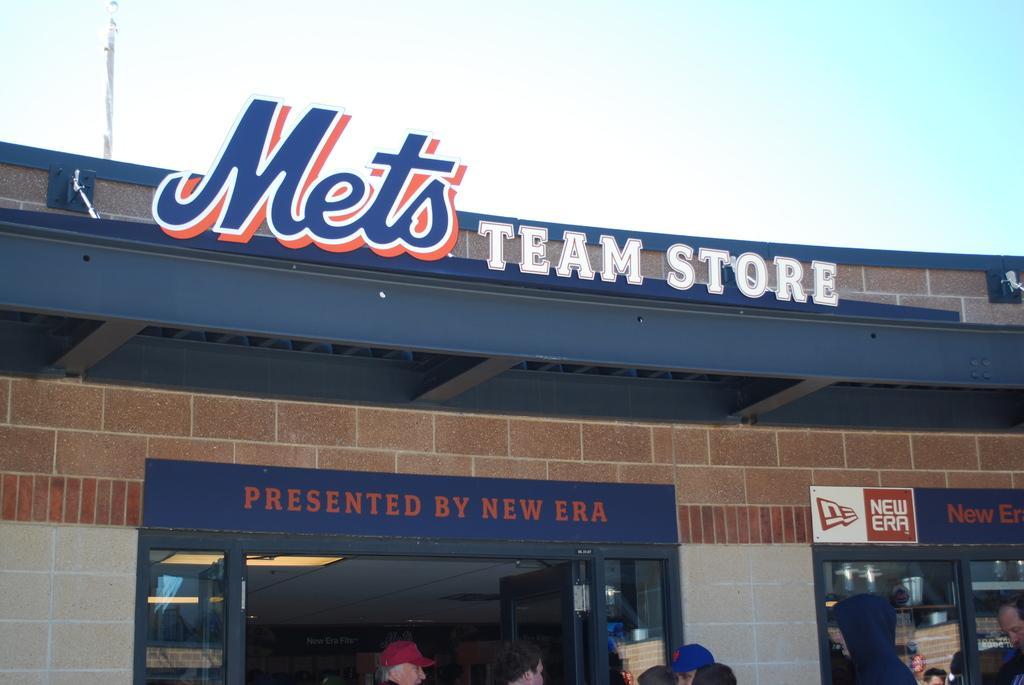How would you summarize this image in a sentence or two? In this picture there are people and we can see store, boards, wall and pole. In the background of the image we can see sky. 